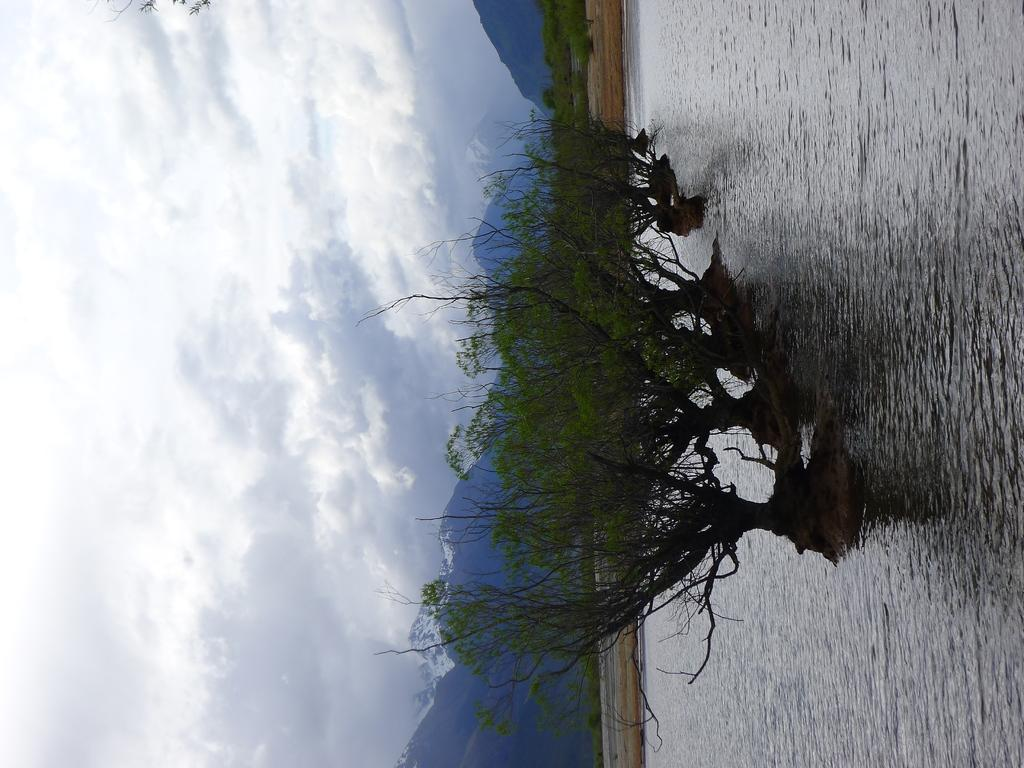What type of natural feature is present on the water in the image? There are trees on the water in the image. What can be seen in the distance in the image? There are mountains in the background of the image. What is visible in the sky in the image? There are clouds visible in the sky. Can you see a hen wearing a collar in the image? There is no hen or collar present in the image. How many eggs are visible in the image? There are no eggs present in the image. 